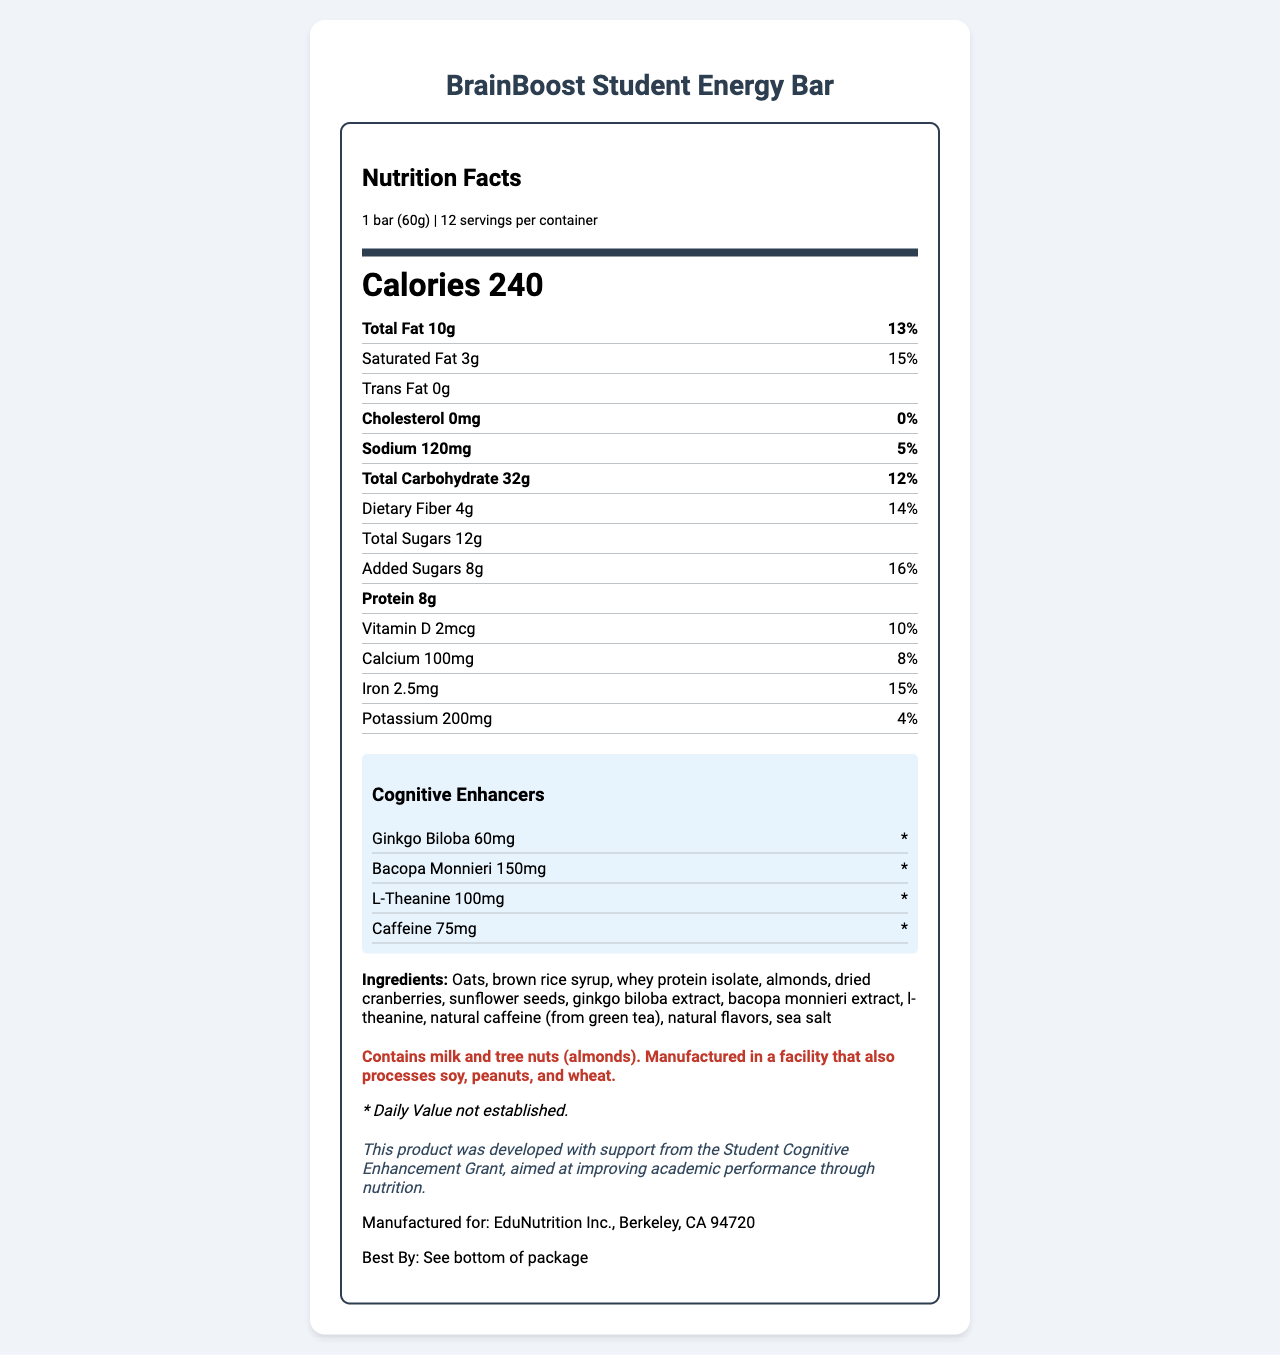what is the serving size of the BrainBoost Student Energy Bar? The serving size is clearly mentioned at the top of the nutrition facts section as "1 bar (60g)".
Answer: 1 bar (60g) How many servings are there per container? The servings per container value is listed right next to the serving size, indicating there are 12 servings per container.
Answer: 12 What is the amount of total fat in one bar? The total fat amount is visible in the nutrition facts section, listed as "Total Fat 10g".
Answer: 10g How much protein does one bar contain? The amount of protein per serving is highlighted in the nutrition facts section as "Protein 8g".
Answer: 8g What is the daily value percentage of dietary fiber in one bar? The daily value percentage for dietary fiber is indicated next to its amount, showing "14%".
Answer: 14% Which of the following cognitive enhancers is included in the highest amount? A. Ginkgo Biloba B. Bacopa Monnieri C. L-Theanine D. Caffeine Bacopa Monnieri is included in the amount of 150mg which is higher than Ginkgo Biloba (60mg), L-Theanine (100mg), and Caffeine (75mg).
Answer: B How many milligrams of calcium are there in one bar? A. 50mg B. 100mg C. 150mg D. 200mg The calcium content per bar is 100mg, as stated in the nutrition facts section.
Answer: B Is there any cholesterol in the BrainBoost Student Energy Bar? The cholesterol amount is listed as 0mg with a daily value of 0%, indicating that there is no cholesterol in the bar.
Answer: No Does the bar contain any added sugars? The nutrition label indicates that there are 8g of added sugars in one bar.
Answer: Yes Summarize the key nutritional and ingredient details of the BrainBoost Student Energy Bar. Explanation: The summary covers the important nutritional values, cognitive enhancers, and ingredient details provided in the nutrition facts label.
Answer: The BrainBoost Student Energy Bar contains 240 calories per serving with 10g of total fat, 3g of saturated fat, no trans fat, 120mg of sodium, 32g of total carbohydrates, 4g of dietary fiber, 12g of total sugars (including 8g of added sugars), and 8g of protein. It also includes cognitive enhancers such as Ginkgo Biloba, Bacopa Monnieri, L-Theanine, and Caffeine. The main ingredients are oats, brown rice syrup, whey protein isolate, almonds, dried cranberries, and sunflower seeds. The bar contains milk and tree nuts and is manufactured in a facility processing soy, peanuts, and wheat. What is the exact expiration or "Best By" date of the product? The document instructs to see the bottom of the package for the "Best By" date, so this information is not provided directly in the document.
Answer: Not enough information 